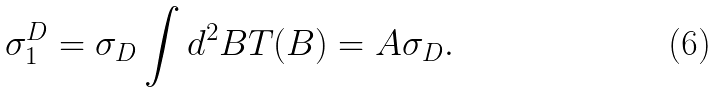Convert formula to latex. <formula><loc_0><loc_0><loc_500><loc_500>\sigma _ { 1 } ^ { D } = \sigma _ { D } \int d ^ { 2 } B T ( B ) = A \sigma _ { D } .</formula> 